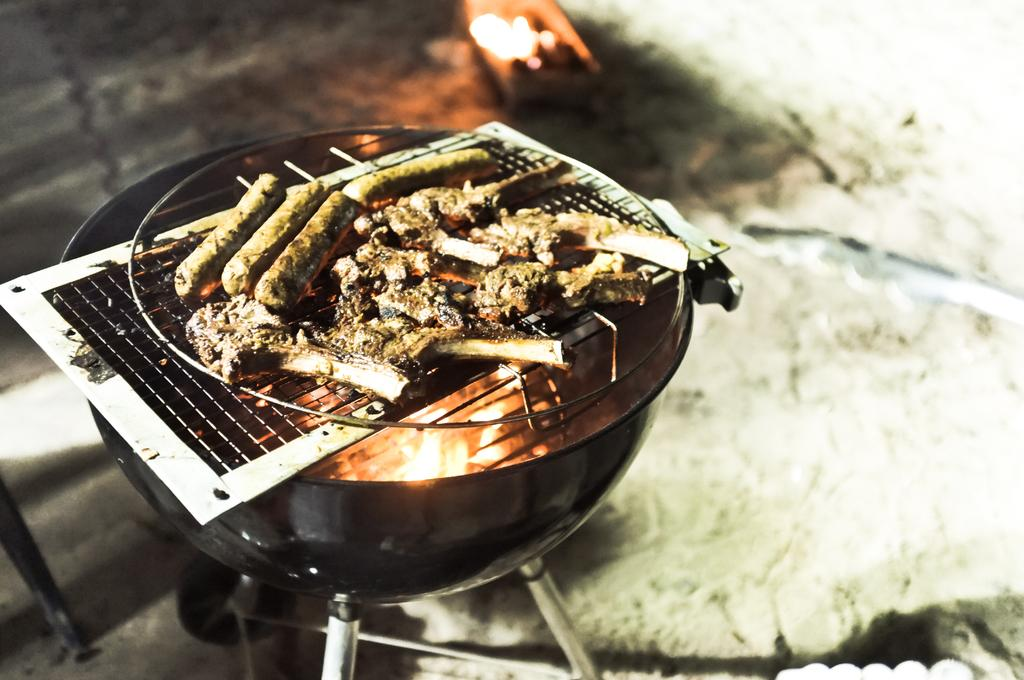What is being cooked in the image? There are food items on a grill in the image. How is the grill being heated in the image? There is a bowl with fire under the grill in the image. Can you describe the background of the image? The background of the image is blurry. What type of class is being taught in the image? There is no class or teaching activity present in the image. 